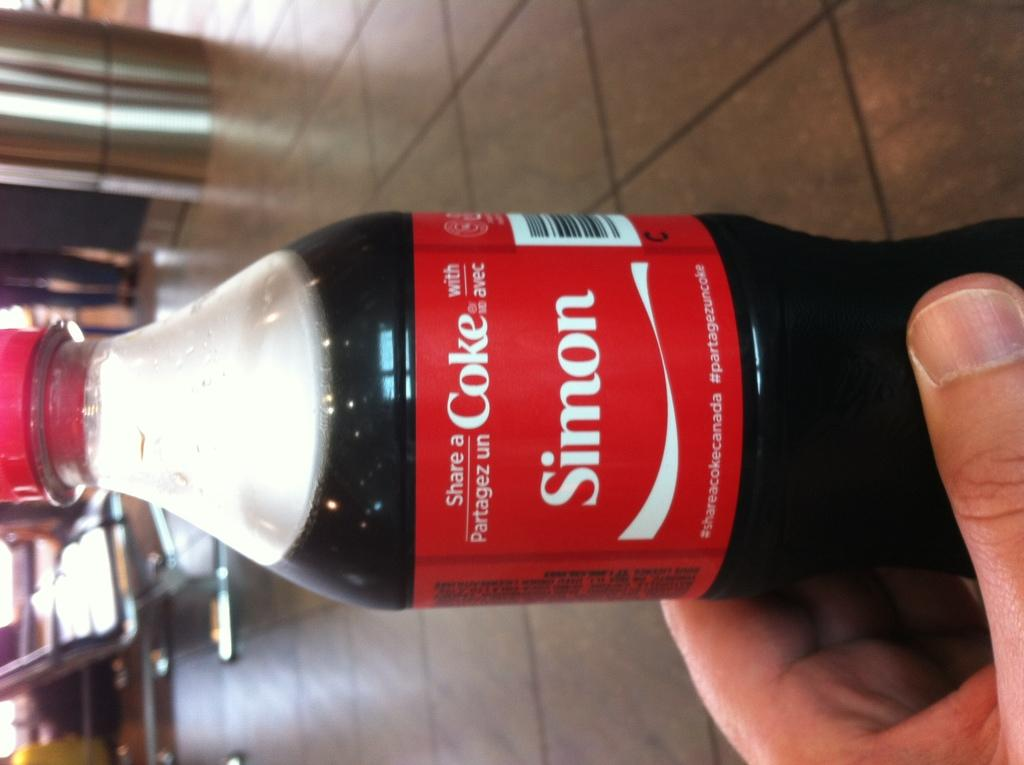<image>
Create a compact narrative representing the image presented. Person holding a Coke bottle with the name Simon on it. 